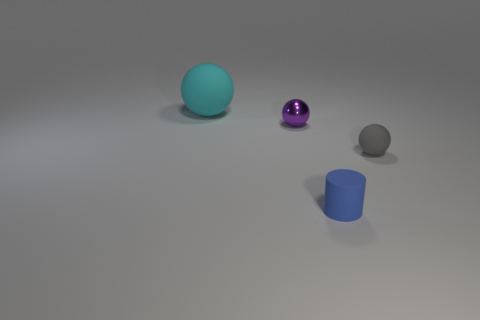Are there any purple balls that are behind the small thing that is behind the matte sphere right of the cyan rubber sphere? Upon carefully examining the image, there are no purple balls positioned behind the small object that is behind the matte sphere to the right of the cyan sphere. The only purple ball visible is located to the left of the cyan sphere and in front of the matte sphere and the small object. 